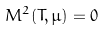<formula> <loc_0><loc_0><loc_500><loc_500>M ^ { 2 } ( T , \mu ) = 0</formula> 